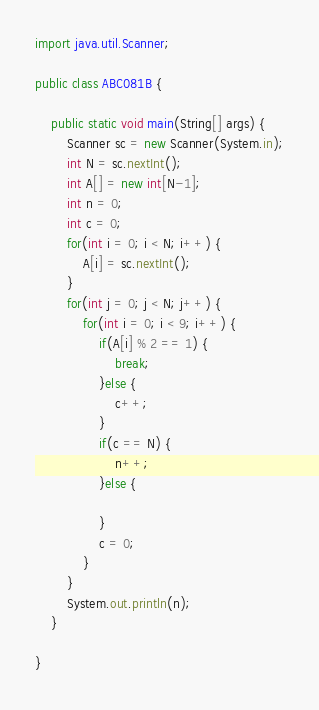Convert code to text. <code><loc_0><loc_0><loc_500><loc_500><_Java_>import java.util.Scanner;

public class ABC081B {

	public static void main(String[] args) {
		Scanner sc = new Scanner(System.in);
		int N = sc.nextInt();
		int A[] = new int[N-1];
		int n = 0;
		int c = 0;
		for(int i = 0; i < N; i++) {
			A[i] = sc.nextInt();
		}
		for(int j = 0; j < N; j++) {
			for(int i = 0; i < 9; i++) {
				if(A[i] % 2 == 1) {
					break;
				}else {
					c++;
				}
				if(c == N) {
					n++;
				}else {
					
				}
				c = 0;
			}
		}
		System.out.println(n);
	}

}
</code> 